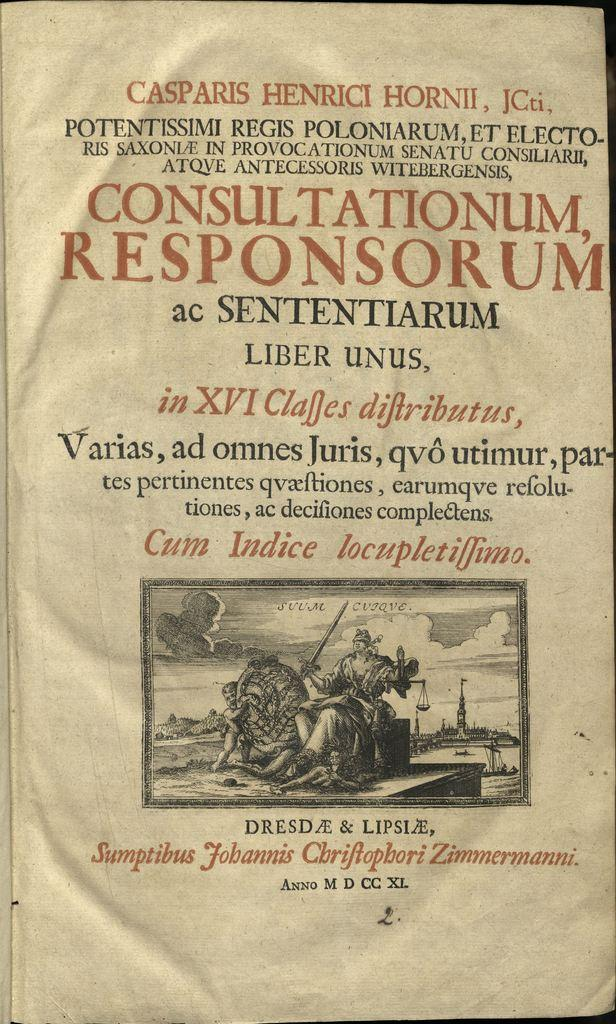<image>
Relay a brief, clear account of the picture shown. Finishing this page from an old book is the line "Anno M D CC XL". 